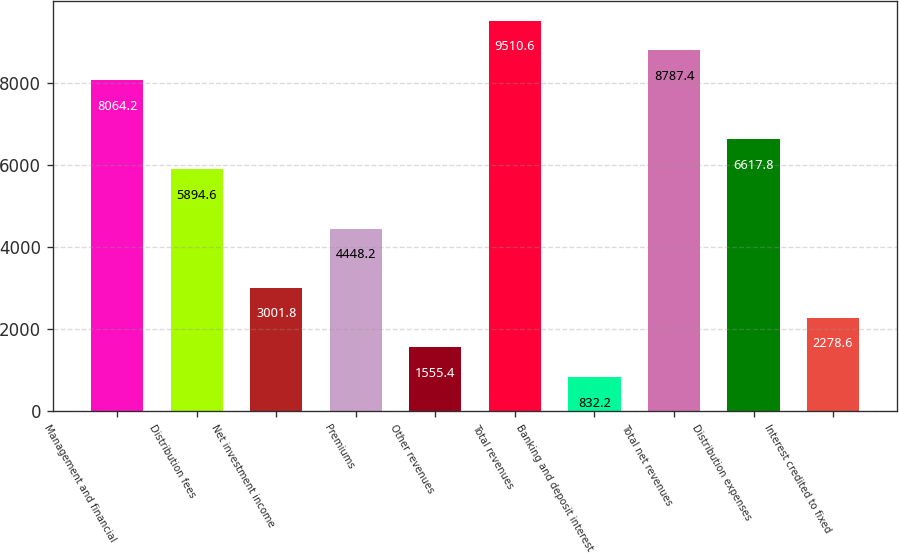Convert chart to OTSL. <chart><loc_0><loc_0><loc_500><loc_500><bar_chart><fcel>Management and financial<fcel>Distribution fees<fcel>Net investment income<fcel>Premiums<fcel>Other revenues<fcel>Total revenues<fcel>Banking and deposit interest<fcel>Total net revenues<fcel>Distribution expenses<fcel>Interest credited to fixed<nl><fcel>8064.2<fcel>5894.6<fcel>3001.8<fcel>4448.2<fcel>1555.4<fcel>9510.6<fcel>832.2<fcel>8787.4<fcel>6617.8<fcel>2278.6<nl></chart> 